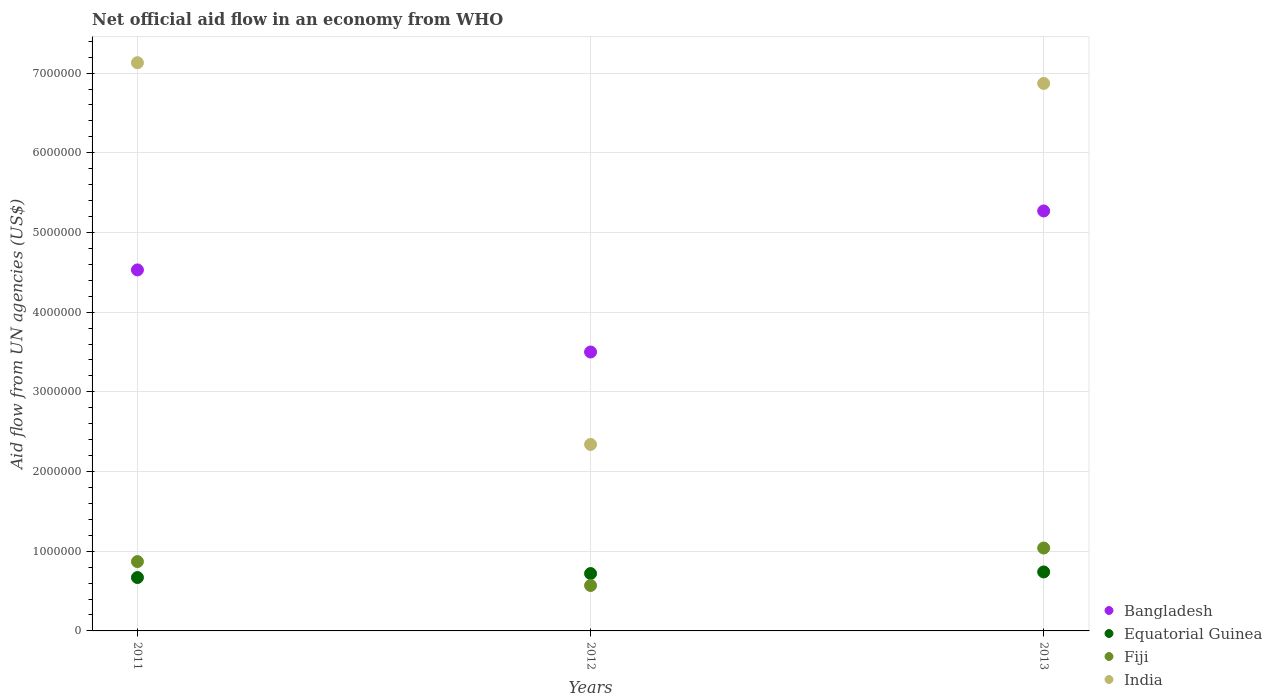Is the number of dotlines equal to the number of legend labels?
Make the answer very short. Yes. What is the net official aid flow in Equatorial Guinea in 2013?
Your answer should be compact. 7.40e+05. Across all years, what is the maximum net official aid flow in India?
Provide a succinct answer. 7.13e+06. Across all years, what is the minimum net official aid flow in Bangladesh?
Provide a succinct answer. 3.50e+06. In which year was the net official aid flow in Equatorial Guinea minimum?
Offer a terse response. 2011. What is the total net official aid flow in Equatorial Guinea in the graph?
Keep it short and to the point. 2.13e+06. What is the difference between the net official aid flow in Bangladesh in 2011 and that in 2012?
Make the answer very short. 1.03e+06. What is the difference between the net official aid flow in Bangladesh in 2013 and the net official aid flow in Equatorial Guinea in 2012?
Keep it short and to the point. 4.55e+06. What is the average net official aid flow in Bangladesh per year?
Make the answer very short. 4.43e+06. In the year 2011, what is the difference between the net official aid flow in Equatorial Guinea and net official aid flow in India?
Provide a succinct answer. -6.46e+06. In how many years, is the net official aid flow in Equatorial Guinea greater than 400000 US$?
Ensure brevity in your answer.  3. What is the ratio of the net official aid flow in Fiji in 2011 to that in 2013?
Your answer should be very brief. 0.84. Is the difference between the net official aid flow in Equatorial Guinea in 2012 and 2013 greater than the difference between the net official aid flow in India in 2012 and 2013?
Ensure brevity in your answer.  Yes. What is the difference between the highest and the second highest net official aid flow in India?
Your answer should be very brief. 2.60e+05. What is the difference between the highest and the lowest net official aid flow in India?
Provide a short and direct response. 4.79e+06. Is the sum of the net official aid flow in India in 2011 and 2013 greater than the maximum net official aid flow in Fiji across all years?
Your answer should be compact. Yes. Is it the case that in every year, the sum of the net official aid flow in Fiji and net official aid flow in Equatorial Guinea  is greater than the net official aid flow in India?
Give a very brief answer. No. Does the net official aid flow in Equatorial Guinea monotonically increase over the years?
Make the answer very short. Yes. Is the net official aid flow in Fiji strictly greater than the net official aid flow in Bangladesh over the years?
Your answer should be compact. No. Are the values on the major ticks of Y-axis written in scientific E-notation?
Offer a very short reply. No. Where does the legend appear in the graph?
Keep it short and to the point. Bottom right. How many legend labels are there?
Give a very brief answer. 4. What is the title of the graph?
Make the answer very short. Net official aid flow in an economy from WHO. What is the label or title of the Y-axis?
Give a very brief answer. Aid flow from UN agencies (US$). What is the Aid flow from UN agencies (US$) in Bangladesh in 2011?
Your answer should be very brief. 4.53e+06. What is the Aid flow from UN agencies (US$) in Equatorial Guinea in 2011?
Keep it short and to the point. 6.70e+05. What is the Aid flow from UN agencies (US$) of Fiji in 2011?
Your answer should be compact. 8.70e+05. What is the Aid flow from UN agencies (US$) in India in 2011?
Your response must be concise. 7.13e+06. What is the Aid flow from UN agencies (US$) in Bangladesh in 2012?
Give a very brief answer. 3.50e+06. What is the Aid flow from UN agencies (US$) of Equatorial Guinea in 2012?
Your answer should be compact. 7.20e+05. What is the Aid flow from UN agencies (US$) in Fiji in 2012?
Offer a very short reply. 5.70e+05. What is the Aid flow from UN agencies (US$) in India in 2012?
Offer a terse response. 2.34e+06. What is the Aid flow from UN agencies (US$) of Bangladesh in 2013?
Provide a short and direct response. 5.27e+06. What is the Aid flow from UN agencies (US$) of Equatorial Guinea in 2013?
Keep it short and to the point. 7.40e+05. What is the Aid flow from UN agencies (US$) of Fiji in 2013?
Provide a succinct answer. 1.04e+06. What is the Aid flow from UN agencies (US$) of India in 2013?
Your answer should be very brief. 6.87e+06. Across all years, what is the maximum Aid flow from UN agencies (US$) of Bangladesh?
Your answer should be compact. 5.27e+06. Across all years, what is the maximum Aid flow from UN agencies (US$) of Equatorial Guinea?
Offer a terse response. 7.40e+05. Across all years, what is the maximum Aid flow from UN agencies (US$) of Fiji?
Keep it short and to the point. 1.04e+06. Across all years, what is the maximum Aid flow from UN agencies (US$) of India?
Provide a succinct answer. 7.13e+06. Across all years, what is the minimum Aid flow from UN agencies (US$) of Bangladesh?
Keep it short and to the point. 3.50e+06. Across all years, what is the minimum Aid flow from UN agencies (US$) of Equatorial Guinea?
Ensure brevity in your answer.  6.70e+05. Across all years, what is the minimum Aid flow from UN agencies (US$) of Fiji?
Ensure brevity in your answer.  5.70e+05. Across all years, what is the minimum Aid flow from UN agencies (US$) of India?
Your answer should be compact. 2.34e+06. What is the total Aid flow from UN agencies (US$) of Bangladesh in the graph?
Offer a terse response. 1.33e+07. What is the total Aid flow from UN agencies (US$) in Equatorial Guinea in the graph?
Ensure brevity in your answer.  2.13e+06. What is the total Aid flow from UN agencies (US$) of Fiji in the graph?
Offer a very short reply. 2.48e+06. What is the total Aid flow from UN agencies (US$) in India in the graph?
Give a very brief answer. 1.63e+07. What is the difference between the Aid flow from UN agencies (US$) in Bangladesh in 2011 and that in 2012?
Make the answer very short. 1.03e+06. What is the difference between the Aid flow from UN agencies (US$) in India in 2011 and that in 2012?
Ensure brevity in your answer.  4.79e+06. What is the difference between the Aid flow from UN agencies (US$) in Bangladesh in 2011 and that in 2013?
Ensure brevity in your answer.  -7.40e+05. What is the difference between the Aid flow from UN agencies (US$) in Equatorial Guinea in 2011 and that in 2013?
Your response must be concise. -7.00e+04. What is the difference between the Aid flow from UN agencies (US$) of Bangladesh in 2012 and that in 2013?
Ensure brevity in your answer.  -1.77e+06. What is the difference between the Aid flow from UN agencies (US$) in Equatorial Guinea in 2012 and that in 2013?
Offer a terse response. -2.00e+04. What is the difference between the Aid flow from UN agencies (US$) of Fiji in 2012 and that in 2013?
Your answer should be very brief. -4.70e+05. What is the difference between the Aid flow from UN agencies (US$) of India in 2012 and that in 2013?
Your answer should be compact. -4.53e+06. What is the difference between the Aid flow from UN agencies (US$) of Bangladesh in 2011 and the Aid flow from UN agencies (US$) of Equatorial Guinea in 2012?
Make the answer very short. 3.81e+06. What is the difference between the Aid flow from UN agencies (US$) of Bangladesh in 2011 and the Aid flow from UN agencies (US$) of Fiji in 2012?
Make the answer very short. 3.96e+06. What is the difference between the Aid flow from UN agencies (US$) in Bangladesh in 2011 and the Aid flow from UN agencies (US$) in India in 2012?
Provide a short and direct response. 2.19e+06. What is the difference between the Aid flow from UN agencies (US$) in Equatorial Guinea in 2011 and the Aid flow from UN agencies (US$) in Fiji in 2012?
Your answer should be very brief. 1.00e+05. What is the difference between the Aid flow from UN agencies (US$) in Equatorial Guinea in 2011 and the Aid flow from UN agencies (US$) in India in 2012?
Provide a succinct answer. -1.67e+06. What is the difference between the Aid flow from UN agencies (US$) in Fiji in 2011 and the Aid flow from UN agencies (US$) in India in 2012?
Ensure brevity in your answer.  -1.47e+06. What is the difference between the Aid flow from UN agencies (US$) in Bangladesh in 2011 and the Aid flow from UN agencies (US$) in Equatorial Guinea in 2013?
Offer a terse response. 3.79e+06. What is the difference between the Aid flow from UN agencies (US$) of Bangladesh in 2011 and the Aid flow from UN agencies (US$) of Fiji in 2013?
Your answer should be very brief. 3.49e+06. What is the difference between the Aid flow from UN agencies (US$) in Bangladesh in 2011 and the Aid flow from UN agencies (US$) in India in 2013?
Ensure brevity in your answer.  -2.34e+06. What is the difference between the Aid flow from UN agencies (US$) of Equatorial Guinea in 2011 and the Aid flow from UN agencies (US$) of Fiji in 2013?
Keep it short and to the point. -3.70e+05. What is the difference between the Aid flow from UN agencies (US$) in Equatorial Guinea in 2011 and the Aid flow from UN agencies (US$) in India in 2013?
Your response must be concise. -6.20e+06. What is the difference between the Aid flow from UN agencies (US$) of Fiji in 2011 and the Aid flow from UN agencies (US$) of India in 2013?
Your answer should be compact. -6.00e+06. What is the difference between the Aid flow from UN agencies (US$) of Bangladesh in 2012 and the Aid flow from UN agencies (US$) of Equatorial Guinea in 2013?
Keep it short and to the point. 2.76e+06. What is the difference between the Aid flow from UN agencies (US$) of Bangladesh in 2012 and the Aid flow from UN agencies (US$) of Fiji in 2013?
Your answer should be very brief. 2.46e+06. What is the difference between the Aid flow from UN agencies (US$) of Bangladesh in 2012 and the Aid flow from UN agencies (US$) of India in 2013?
Your response must be concise. -3.37e+06. What is the difference between the Aid flow from UN agencies (US$) of Equatorial Guinea in 2012 and the Aid flow from UN agencies (US$) of Fiji in 2013?
Provide a succinct answer. -3.20e+05. What is the difference between the Aid flow from UN agencies (US$) in Equatorial Guinea in 2012 and the Aid flow from UN agencies (US$) in India in 2013?
Offer a very short reply. -6.15e+06. What is the difference between the Aid flow from UN agencies (US$) of Fiji in 2012 and the Aid flow from UN agencies (US$) of India in 2013?
Make the answer very short. -6.30e+06. What is the average Aid flow from UN agencies (US$) in Bangladesh per year?
Your answer should be very brief. 4.43e+06. What is the average Aid flow from UN agencies (US$) of Equatorial Guinea per year?
Provide a succinct answer. 7.10e+05. What is the average Aid flow from UN agencies (US$) of Fiji per year?
Offer a terse response. 8.27e+05. What is the average Aid flow from UN agencies (US$) of India per year?
Your response must be concise. 5.45e+06. In the year 2011, what is the difference between the Aid flow from UN agencies (US$) of Bangladesh and Aid flow from UN agencies (US$) of Equatorial Guinea?
Ensure brevity in your answer.  3.86e+06. In the year 2011, what is the difference between the Aid flow from UN agencies (US$) in Bangladesh and Aid flow from UN agencies (US$) in Fiji?
Keep it short and to the point. 3.66e+06. In the year 2011, what is the difference between the Aid flow from UN agencies (US$) of Bangladesh and Aid flow from UN agencies (US$) of India?
Give a very brief answer. -2.60e+06. In the year 2011, what is the difference between the Aid flow from UN agencies (US$) of Equatorial Guinea and Aid flow from UN agencies (US$) of India?
Your answer should be very brief. -6.46e+06. In the year 2011, what is the difference between the Aid flow from UN agencies (US$) of Fiji and Aid flow from UN agencies (US$) of India?
Make the answer very short. -6.26e+06. In the year 2012, what is the difference between the Aid flow from UN agencies (US$) of Bangladesh and Aid flow from UN agencies (US$) of Equatorial Guinea?
Your answer should be compact. 2.78e+06. In the year 2012, what is the difference between the Aid flow from UN agencies (US$) in Bangladesh and Aid flow from UN agencies (US$) in Fiji?
Give a very brief answer. 2.93e+06. In the year 2012, what is the difference between the Aid flow from UN agencies (US$) of Bangladesh and Aid flow from UN agencies (US$) of India?
Your response must be concise. 1.16e+06. In the year 2012, what is the difference between the Aid flow from UN agencies (US$) in Equatorial Guinea and Aid flow from UN agencies (US$) in Fiji?
Offer a very short reply. 1.50e+05. In the year 2012, what is the difference between the Aid flow from UN agencies (US$) in Equatorial Guinea and Aid flow from UN agencies (US$) in India?
Ensure brevity in your answer.  -1.62e+06. In the year 2012, what is the difference between the Aid flow from UN agencies (US$) of Fiji and Aid flow from UN agencies (US$) of India?
Ensure brevity in your answer.  -1.77e+06. In the year 2013, what is the difference between the Aid flow from UN agencies (US$) in Bangladesh and Aid flow from UN agencies (US$) in Equatorial Guinea?
Provide a succinct answer. 4.53e+06. In the year 2013, what is the difference between the Aid flow from UN agencies (US$) in Bangladesh and Aid flow from UN agencies (US$) in Fiji?
Offer a very short reply. 4.23e+06. In the year 2013, what is the difference between the Aid flow from UN agencies (US$) in Bangladesh and Aid flow from UN agencies (US$) in India?
Keep it short and to the point. -1.60e+06. In the year 2013, what is the difference between the Aid flow from UN agencies (US$) in Equatorial Guinea and Aid flow from UN agencies (US$) in Fiji?
Give a very brief answer. -3.00e+05. In the year 2013, what is the difference between the Aid flow from UN agencies (US$) of Equatorial Guinea and Aid flow from UN agencies (US$) of India?
Your answer should be very brief. -6.13e+06. In the year 2013, what is the difference between the Aid flow from UN agencies (US$) in Fiji and Aid flow from UN agencies (US$) in India?
Keep it short and to the point. -5.83e+06. What is the ratio of the Aid flow from UN agencies (US$) of Bangladesh in 2011 to that in 2012?
Give a very brief answer. 1.29. What is the ratio of the Aid flow from UN agencies (US$) of Equatorial Guinea in 2011 to that in 2012?
Your answer should be compact. 0.93. What is the ratio of the Aid flow from UN agencies (US$) of Fiji in 2011 to that in 2012?
Offer a terse response. 1.53. What is the ratio of the Aid flow from UN agencies (US$) in India in 2011 to that in 2012?
Keep it short and to the point. 3.05. What is the ratio of the Aid flow from UN agencies (US$) of Bangladesh in 2011 to that in 2013?
Make the answer very short. 0.86. What is the ratio of the Aid flow from UN agencies (US$) in Equatorial Guinea in 2011 to that in 2013?
Ensure brevity in your answer.  0.91. What is the ratio of the Aid flow from UN agencies (US$) in Fiji in 2011 to that in 2013?
Give a very brief answer. 0.84. What is the ratio of the Aid flow from UN agencies (US$) in India in 2011 to that in 2013?
Make the answer very short. 1.04. What is the ratio of the Aid flow from UN agencies (US$) in Bangladesh in 2012 to that in 2013?
Offer a terse response. 0.66. What is the ratio of the Aid flow from UN agencies (US$) of Equatorial Guinea in 2012 to that in 2013?
Give a very brief answer. 0.97. What is the ratio of the Aid flow from UN agencies (US$) in Fiji in 2012 to that in 2013?
Offer a very short reply. 0.55. What is the ratio of the Aid flow from UN agencies (US$) of India in 2012 to that in 2013?
Provide a short and direct response. 0.34. What is the difference between the highest and the second highest Aid flow from UN agencies (US$) of Bangladesh?
Offer a terse response. 7.40e+05. What is the difference between the highest and the second highest Aid flow from UN agencies (US$) in Equatorial Guinea?
Offer a terse response. 2.00e+04. What is the difference between the highest and the second highest Aid flow from UN agencies (US$) in Fiji?
Your answer should be very brief. 1.70e+05. What is the difference between the highest and the second highest Aid flow from UN agencies (US$) of India?
Ensure brevity in your answer.  2.60e+05. What is the difference between the highest and the lowest Aid flow from UN agencies (US$) in Bangladesh?
Make the answer very short. 1.77e+06. What is the difference between the highest and the lowest Aid flow from UN agencies (US$) in Equatorial Guinea?
Your answer should be compact. 7.00e+04. What is the difference between the highest and the lowest Aid flow from UN agencies (US$) of India?
Offer a terse response. 4.79e+06. 